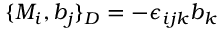Convert formula to latex. <formula><loc_0><loc_0><loc_500><loc_500>\{ M _ { i } , b _ { j } \} _ { D } = - \epsilon _ { i j k } b _ { k }</formula> 